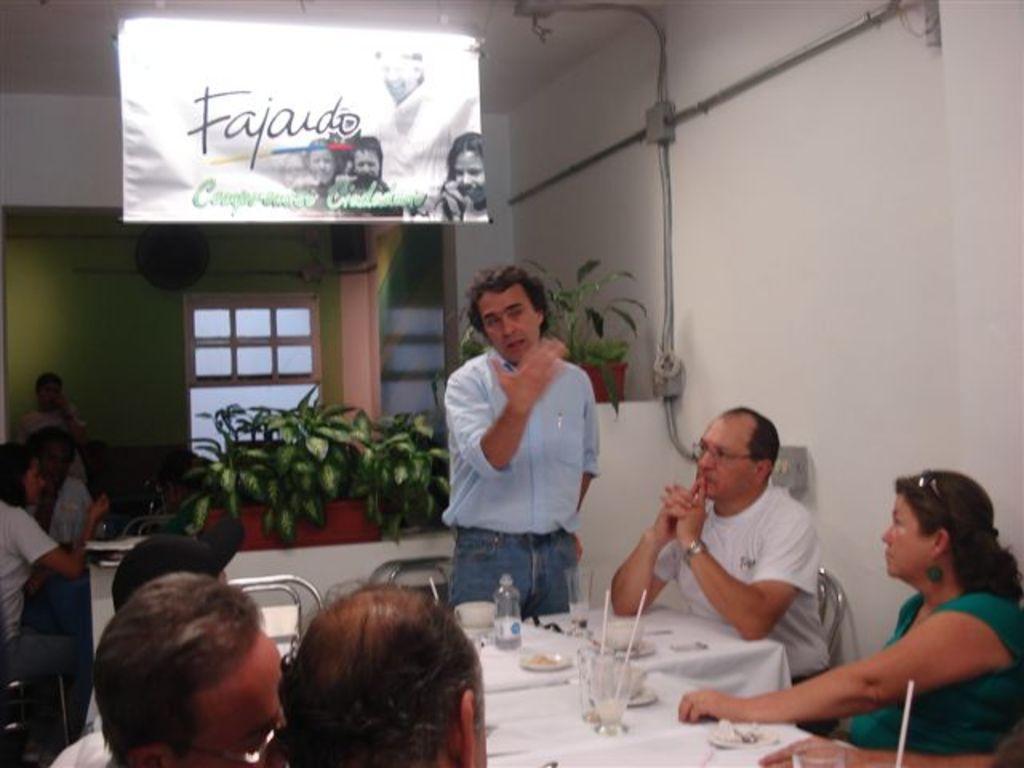How would you summarize this image in a sentence or two? This is a picture taken in a room, there are a group of people who are sitting on a chair and a man in blue shirt explaining something. Background of this people is a hose plants and a banner is hanging to the roof and a wall which is in green color. There are some other people sitting behind the house plants. 